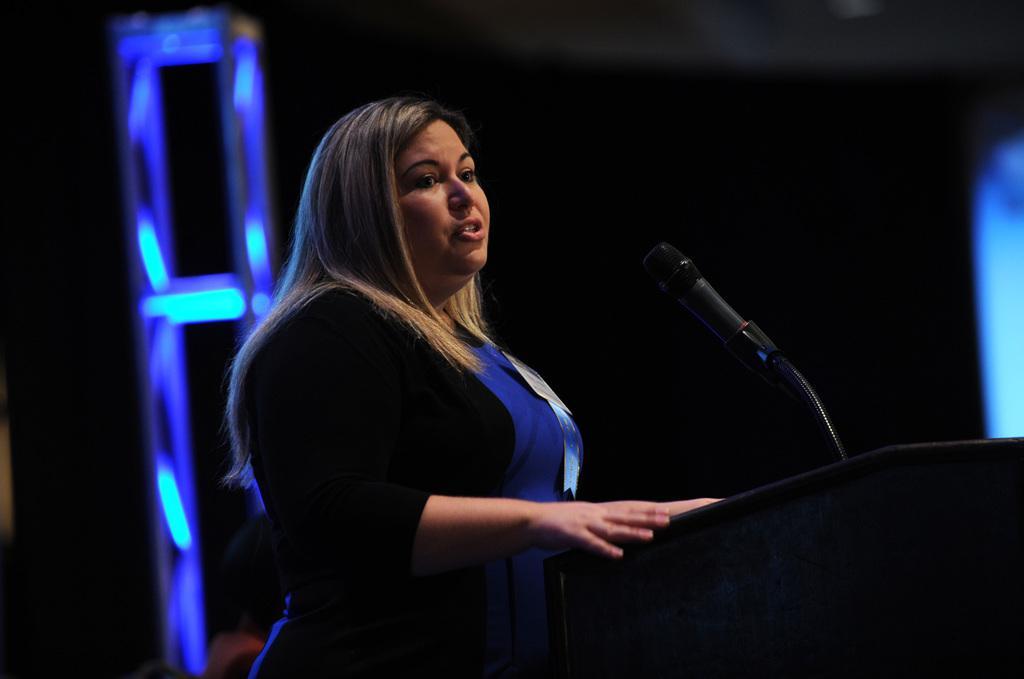Could you give a brief overview of what you see in this image? In this image I can see a woman wearing black and blue colored dress is standing in front of the black colored podium. I can see a microphone in front of her. I can see the black and blue colored background. 